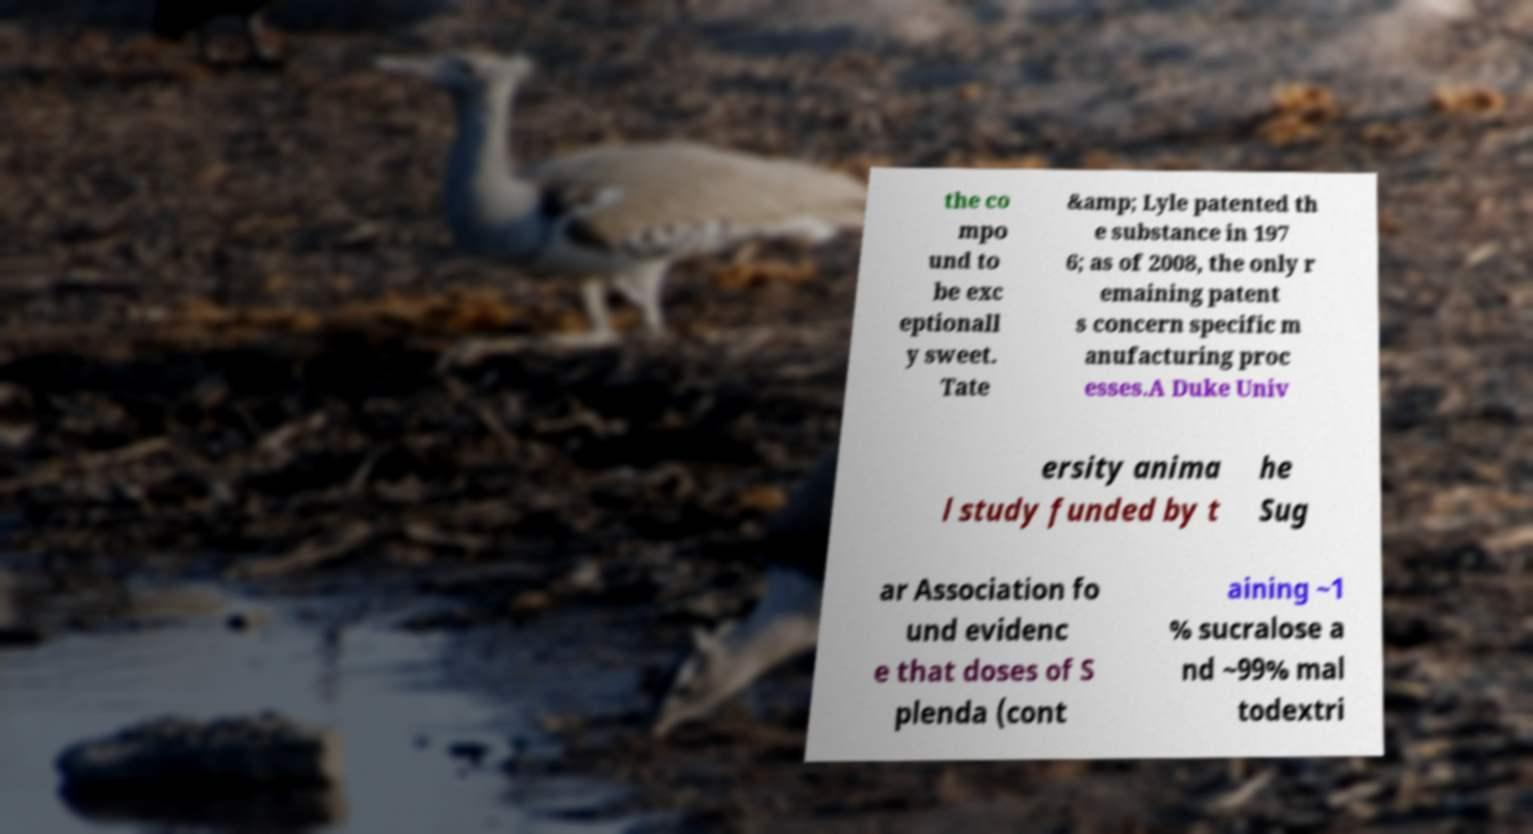Please read and relay the text visible in this image. What does it say? the co mpo und to be exc eptionall y sweet. Tate &amp; Lyle patented th e substance in 197 6; as of 2008, the only r emaining patent s concern specific m anufacturing proc esses.A Duke Univ ersity anima l study funded by t he Sug ar Association fo und evidenc e that doses of S plenda (cont aining ~1 % sucralose a nd ~99% mal todextri 